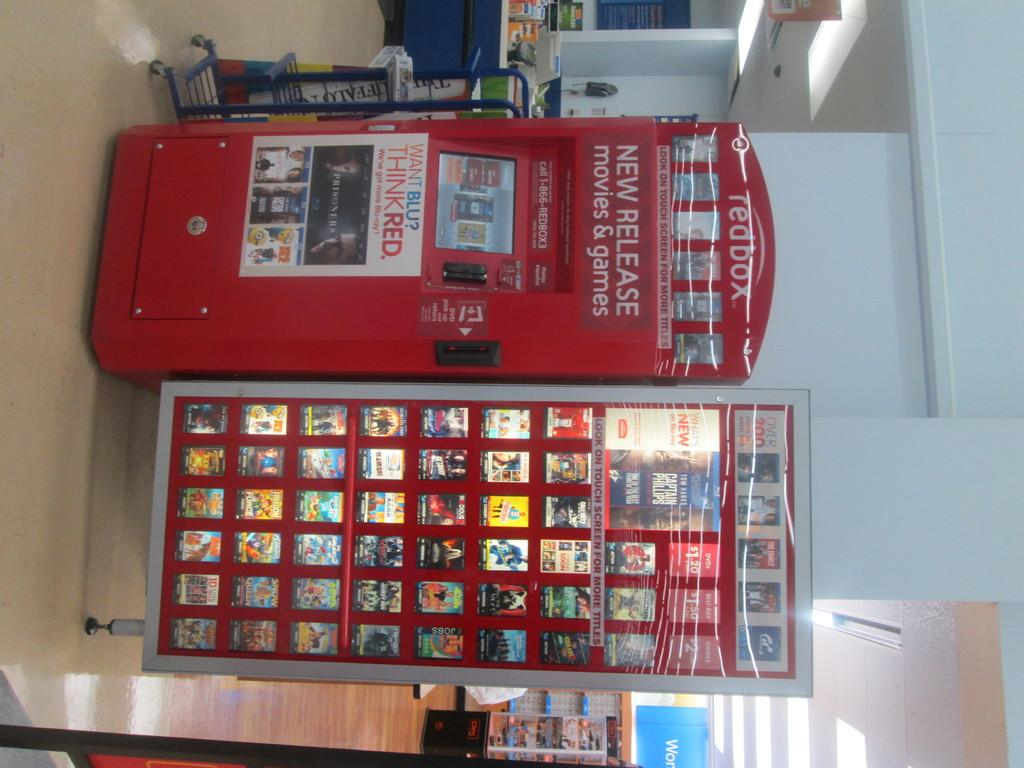Provide a one-sentence caption for the provided image. A Red Box vending machine with print telling you the vending box contains new release movies and games. 